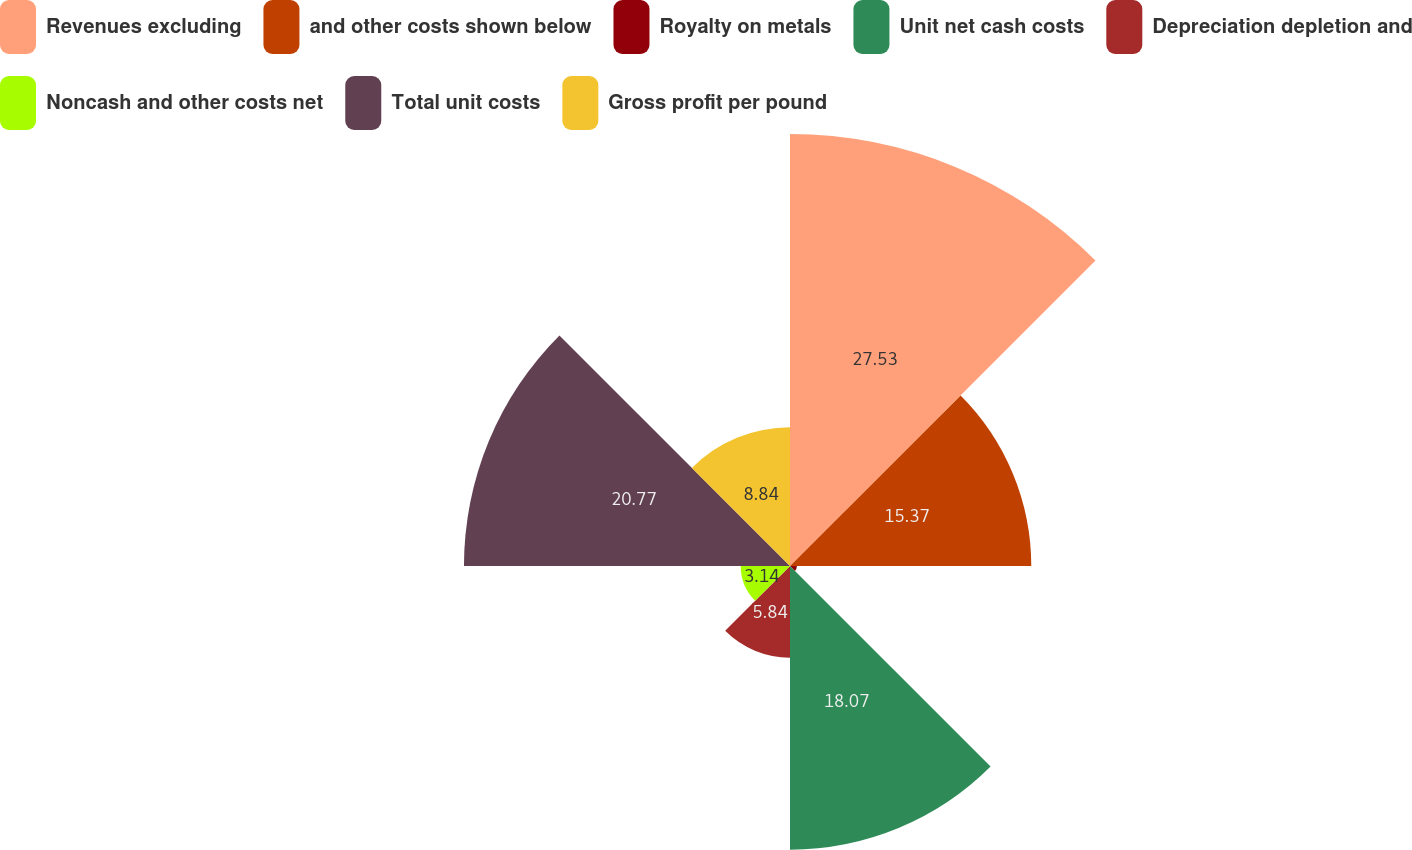Convert chart. <chart><loc_0><loc_0><loc_500><loc_500><pie_chart><fcel>Revenues excluding<fcel>and other costs shown below<fcel>Royalty on metals<fcel>Unit net cash costs<fcel>Depreciation depletion and<fcel>Noncash and other costs net<fcel>Total unit costs<fcel>Gross profit per pound<nl><fcel>27.52%<fcel>15.37%<fcel>0.44%<fcel>18.07%<fcel>5.84%<fcel>3.14%<fcel>20.77%<fcel>8.84%<nl></chart> 